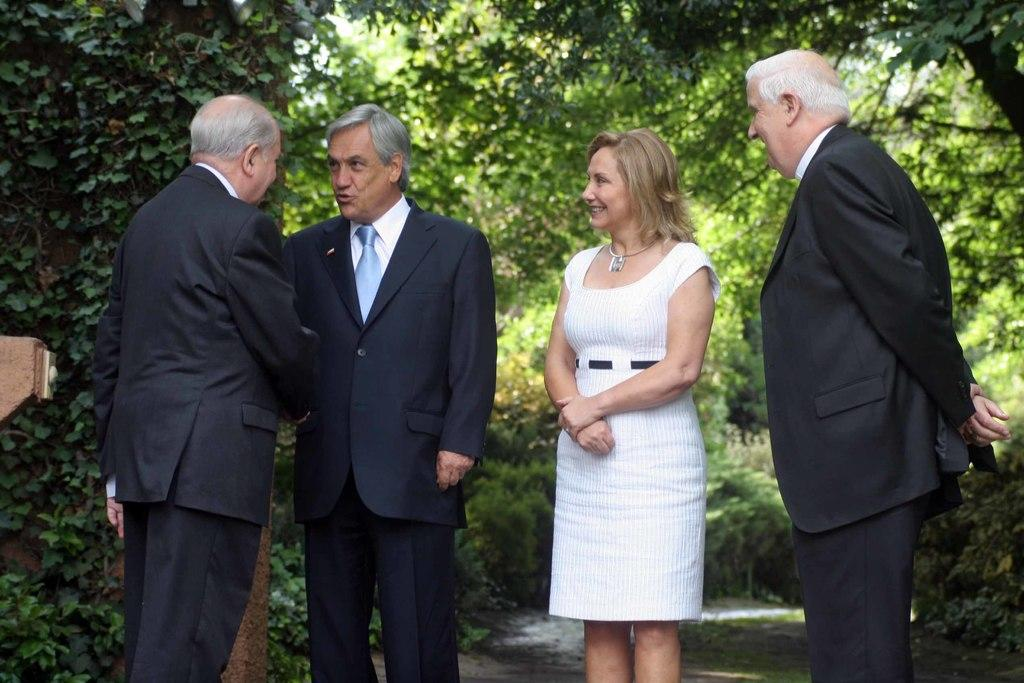How many people are in the image? There is a group of people in the image. Where are the people located in the image? The people are standing together on a road. What can be seen in the background of the image? There are trees visible in the background of the image. What type of playground equipment can be seen in the image? There is no playground equipment present in the image. 